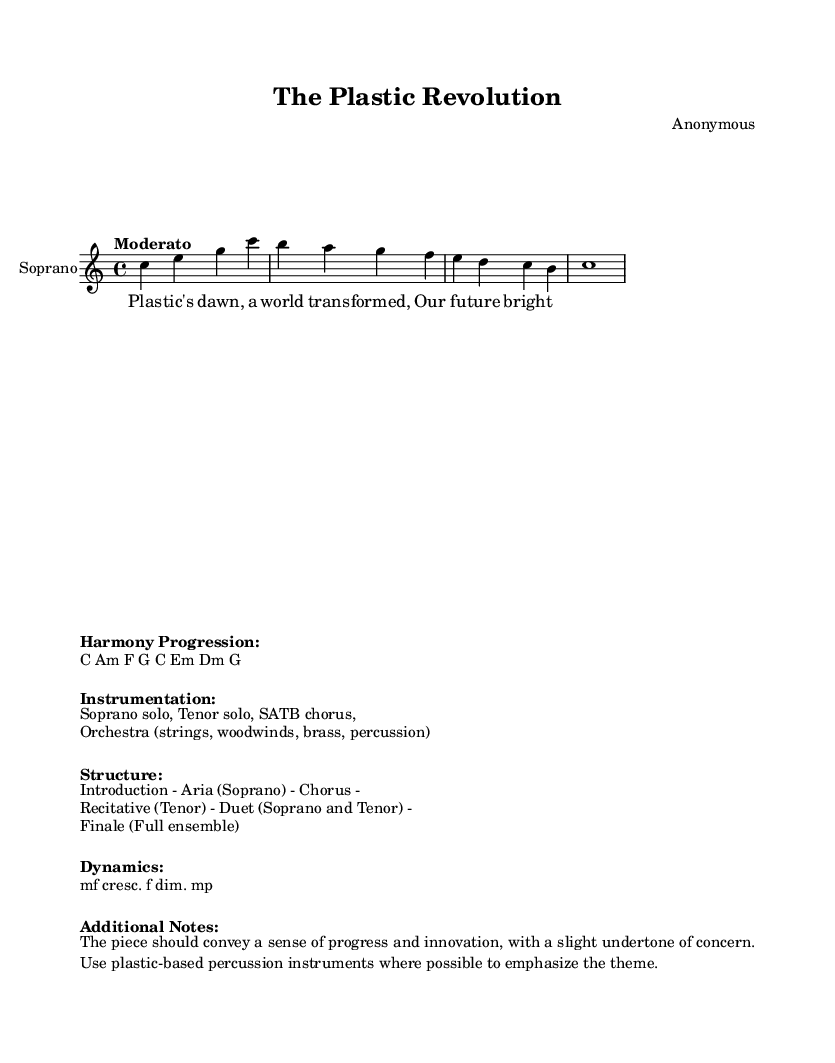What is the key signature of this music? The key signature is C major, which is indicated by having no sharps or flats in the key signature section of the sheet music.
Answer: C major What is the time signature of this music? The time signature is indicated at the beginning of the score, showing a measure containing 4 beats, which corresponds to the 4/4 notation.
Answer: 4/4 What is the tempo marking for this piece? The tempo marking "Moderato" indicates the speed of the piece, suggesting a moderate pace.
Answer: Moderato How many vocal parts are included in the instrumentation? The instrumentation includes a Soprano solo and a Tenor solo, which makes it two vocal parts.
Answer: 2 What is the structure of this opera? The structure consists of an Introduction, Aria (Soprano), Chorus, Recitative (Tenor), Duet (Soprano and Tenor), and Finale (Full ensemble), showing a diverse arrangement of sections typical for opera.
Answer: Introduction - Aria (Soprano) - Chorus - Recitative (Tenor) - Duet (Soprano and Tenor) - Finale (Full ensemble) What kind of instruments are suggested for percussion? The additional notes emphasize the use of plastic-based percussion instruments to enhance the thematic connection to plastic manufacturing, making this a unique suggestion for percussion instrumentation.
Answer: Plastic-based percussion instruments 